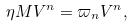<formula> <loc_0><loc_0><loc_500><loc_500>\eta M V ^ { n } = \varpi _ { n } V ^ { n } ,</formula> 